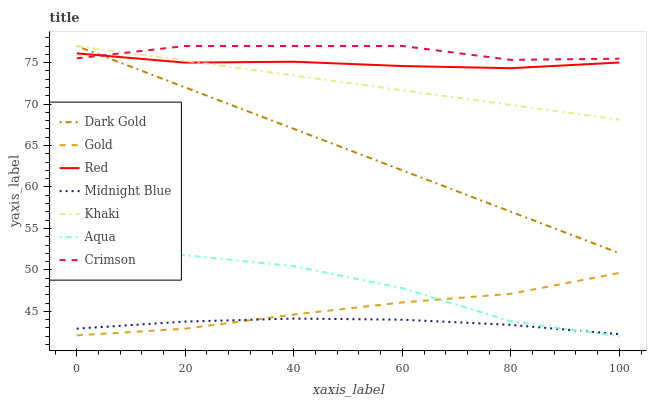Does Midnight Blue have the minimum area under the curve?
Answer yes or no. Yes. Does Crimson have the maximum area under the curve?
Answer yes or no. Yes. Does Gold have the minimum area under the curve?
Answer yes or no. No. Does Gold have the maximum area under the curve?
Answer yes or no. No. Is Dark Gold the smoothest?
Answer yes or no. Yes. Is Aqua the roughest?
Answer yes or no. Yes. Is Midnight Blue the smoothest?
Answer yes or no. No. Is Midnight Blue the roughest?
Answer yes or no. No. Does Aqua have the lowest value?
Answer yes or no. Yes. Does Midnight Blue have the lowest value?
Answer yes or no. No. Does Crimson have the highest value?
Answer yes or no. Yes. Does Gold have the highest value?
Answer yes or no. No. Is Gold less than Red?
Answer yes or no. Yes. Is Crimson greater than Aqua?
Answer yes or no. Yes. Does Khaki intersect Crimson?
Answer yes or no. Yes. Is Khaki less than Crimson?
Answer yes or no. No. Is Khaki greater than Crimson?
Answer yes or no. No. Does Gold intersect Red?
Answer yes or no. No. 